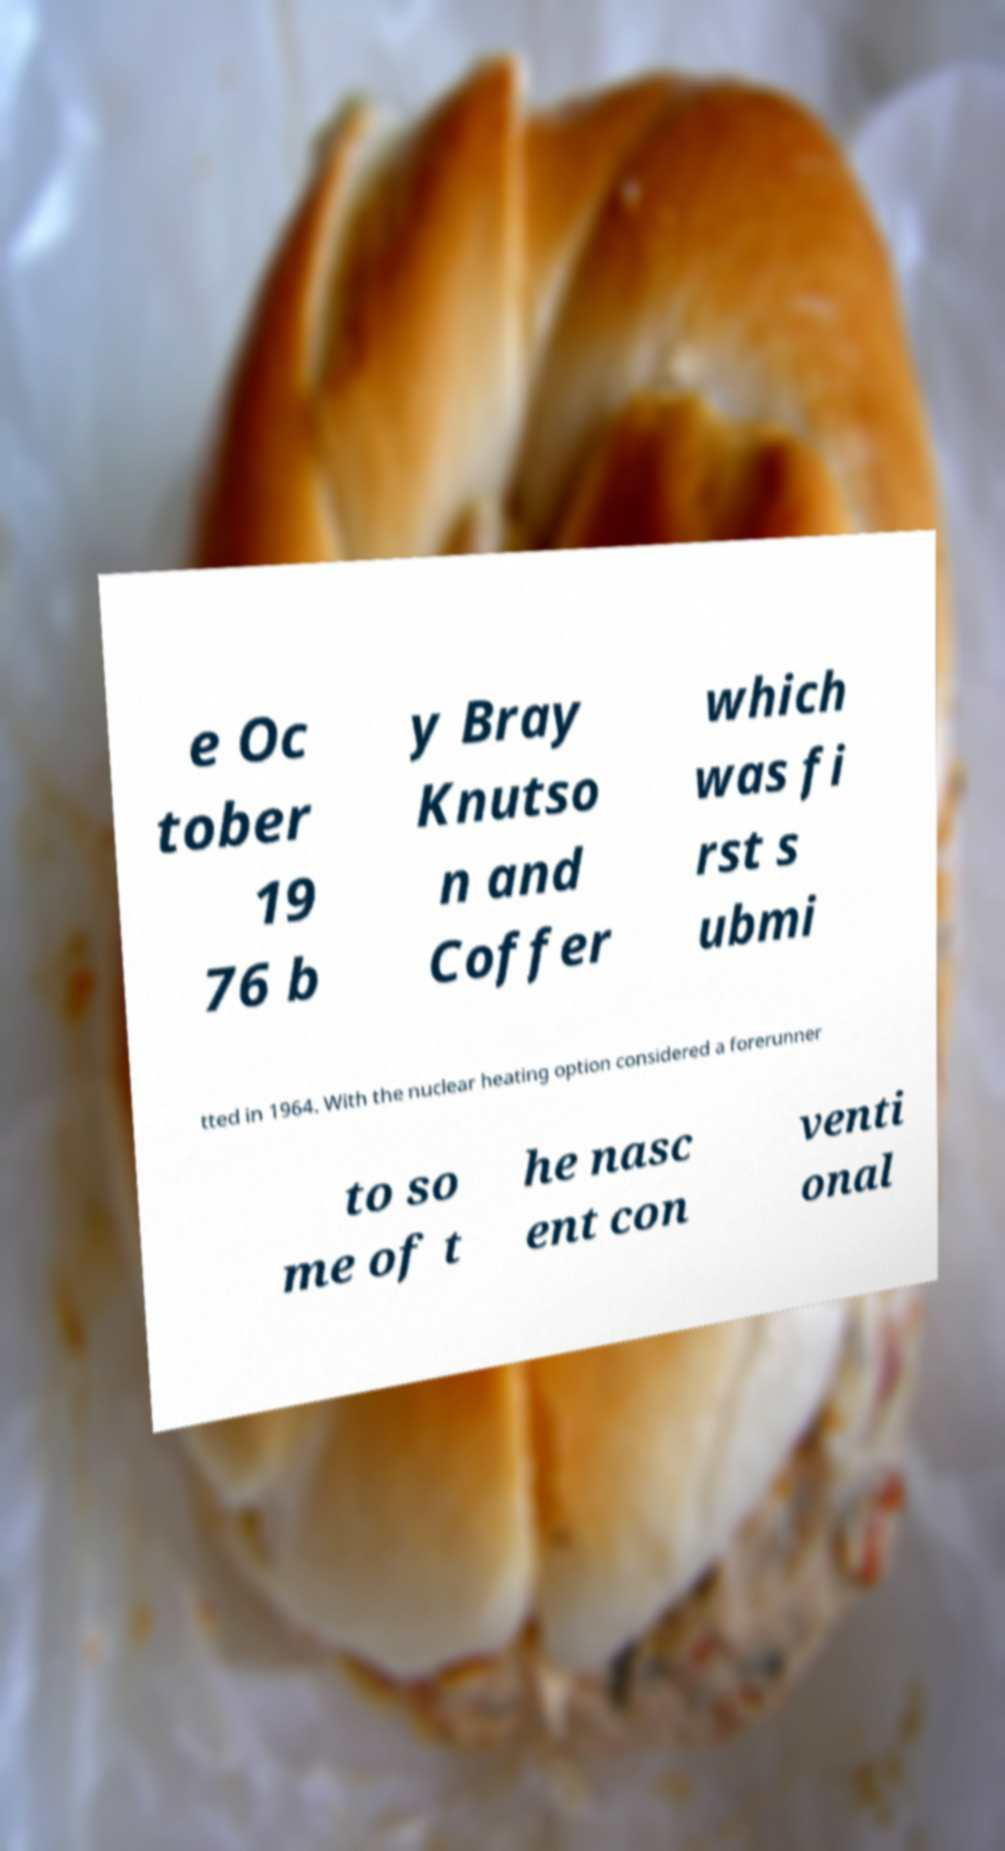Please identify and transcribe the text found in this image. e Oc tober 19 76 b y Bray Knutso n and Coffer which was fi rst s ubmi tted in 1964. With the nuclear heating option considered a forerunner to so me of t he nasc ent con venti onal 